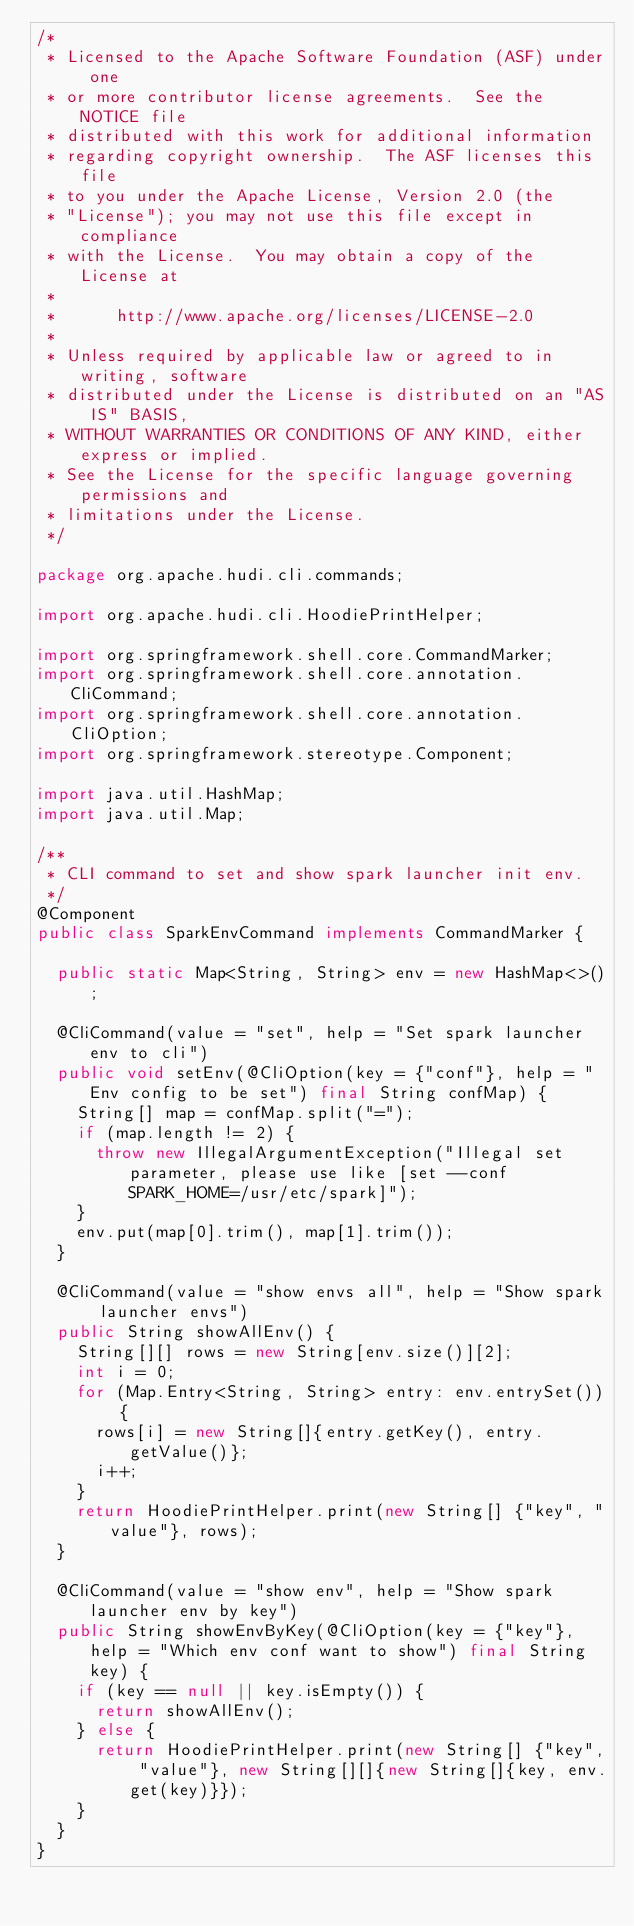Convert code to text. <code><loc_0><loc_0><loc_500><loc_500><_Java_>/*
 * Licensed to the Apache Software Foundation (ASF) under one
 * or more contributor license agreements.  See the NOTICE file
 * distributed with this work for additional information
 * regarding copyright ownership.  The ASF licenses this file
 * to you under the Apache License, Version 2.0 (the
 * "License"); you may not use this file except in compliance
 * with the License.  You may obtain a copy of the License at
 *
 *      http://www.apache.org/licenses/LICENSE-2.0
 *
 * Unless required by applicable law or agreed to in writing, software
 * distributed under the License is distributed on an "AS IS" BASIS,
 * WITHOUT WARRANTIES OR CONDITIONS OF ANY KIND, either express or implied.
 * See the License for the specific language governing permissions and
 * limitations under the License.
 */

package org.apache.hudi.cli.commands;

import org.apache.hudi.cli.HoodiePrintHelper;

import org.springframework.shell.core.CommandMarker;
import org.springframework.shell.core.annotation.CliCommand;
import org.springframework.shell.core.annotation.CliOption;
import org.springframework.stereotype.Component;

import java.util.HashMap;
import java.util.Map;

/**
 * CLI command to set and show spark launcher init env.
 */
@Component
public class SparkEnvCommand implements CommandMarker {

  public static Map<String, String> env = new HashMap<>();

  @CliCommand(value = "set", help = "Set spark launcher env to cli")
  public void setEnv(@CliOption(key = {"conf"}, help = "Env config to be set") final String confMap) {
    String[] map = confMap.split("=");
    if (map.length != 2) {
      throw new IllegalArgumentException("Illegal set parameter, please use like [set --conf SPARK_HOME=/usr/etc/spark]");
    }
    env.put(map[0].trim(), map[1].trim());
  }

  @CliCommand(value = "show envs all", help = "Show spark launcher envs")
  public String showAllEnv() {
    String[][] rows = new String[env.size()][2];
    int i = 0;
    for (Map.Entry<String, String> entry: env.entrySet()) {
      rows[i] = new String[]{entry.getKey(), entry.getValue()};
      i++;
    }
    return HoodiePrintHelper.print(new String[] {"key", "value"}, rows);
  }

  @CliCommand(value = "show env", help = "Show spark launcher env by key")
  public String showEnvByKey(@CliOption(key = {"key"}, help = "Which env conf want to show") final String key) {
    if (key == null || key.isEmpty()) {
      return showAllEnv();
    } else {
      return HoodiePrintHelper.print(new String[] {"key", "value"}, new String[][]{new String[]{key, env.get(key)}});
    }
  }
}
</code> 